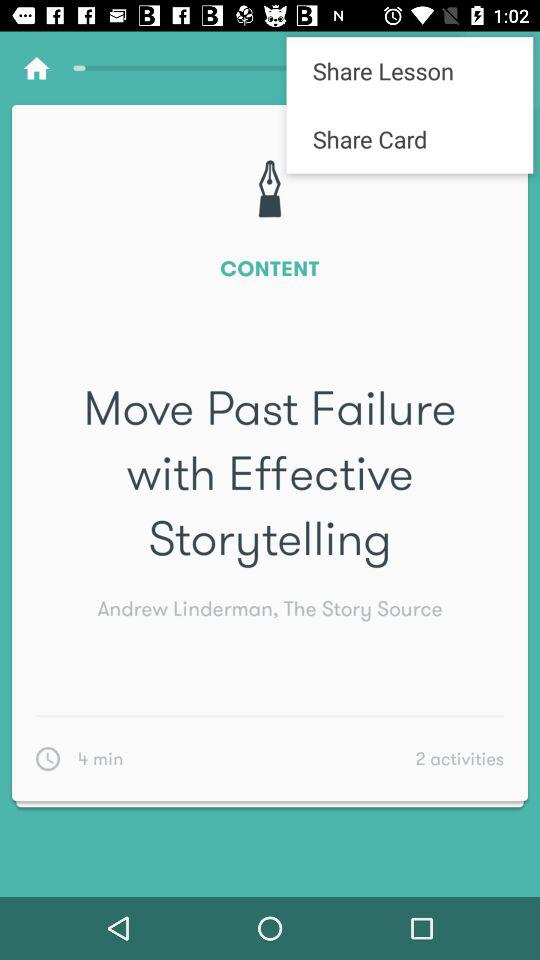What is the reading length? The reading length is 4 minutes. 